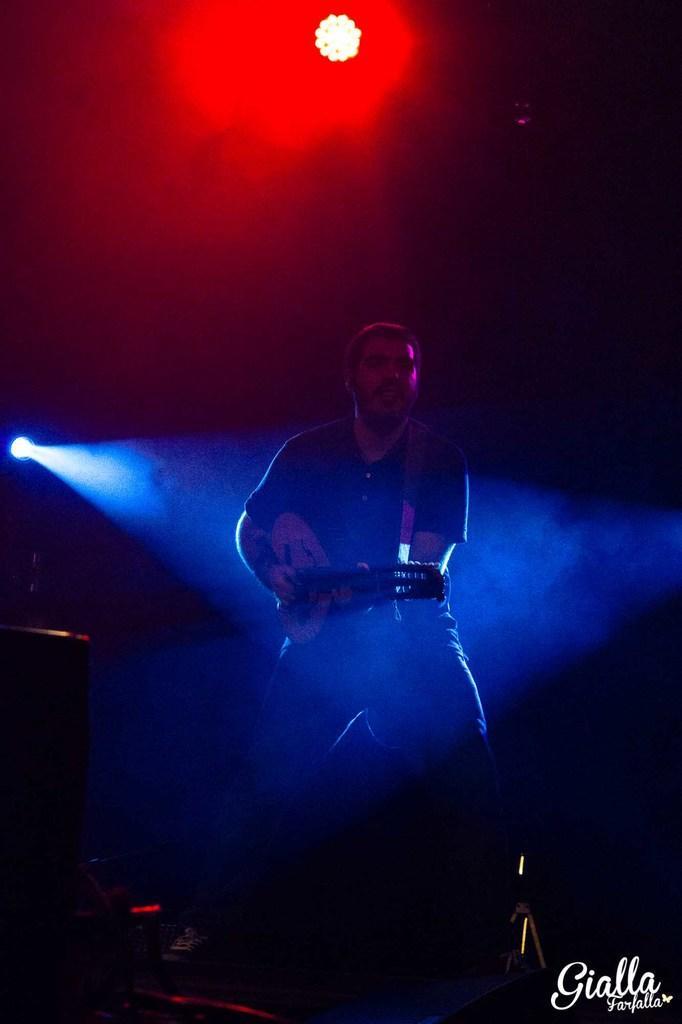In one or two sentences, can you explain what this image depicts? As we can see in the image there is a man holding guitar and there are lights. The image is little dark. 